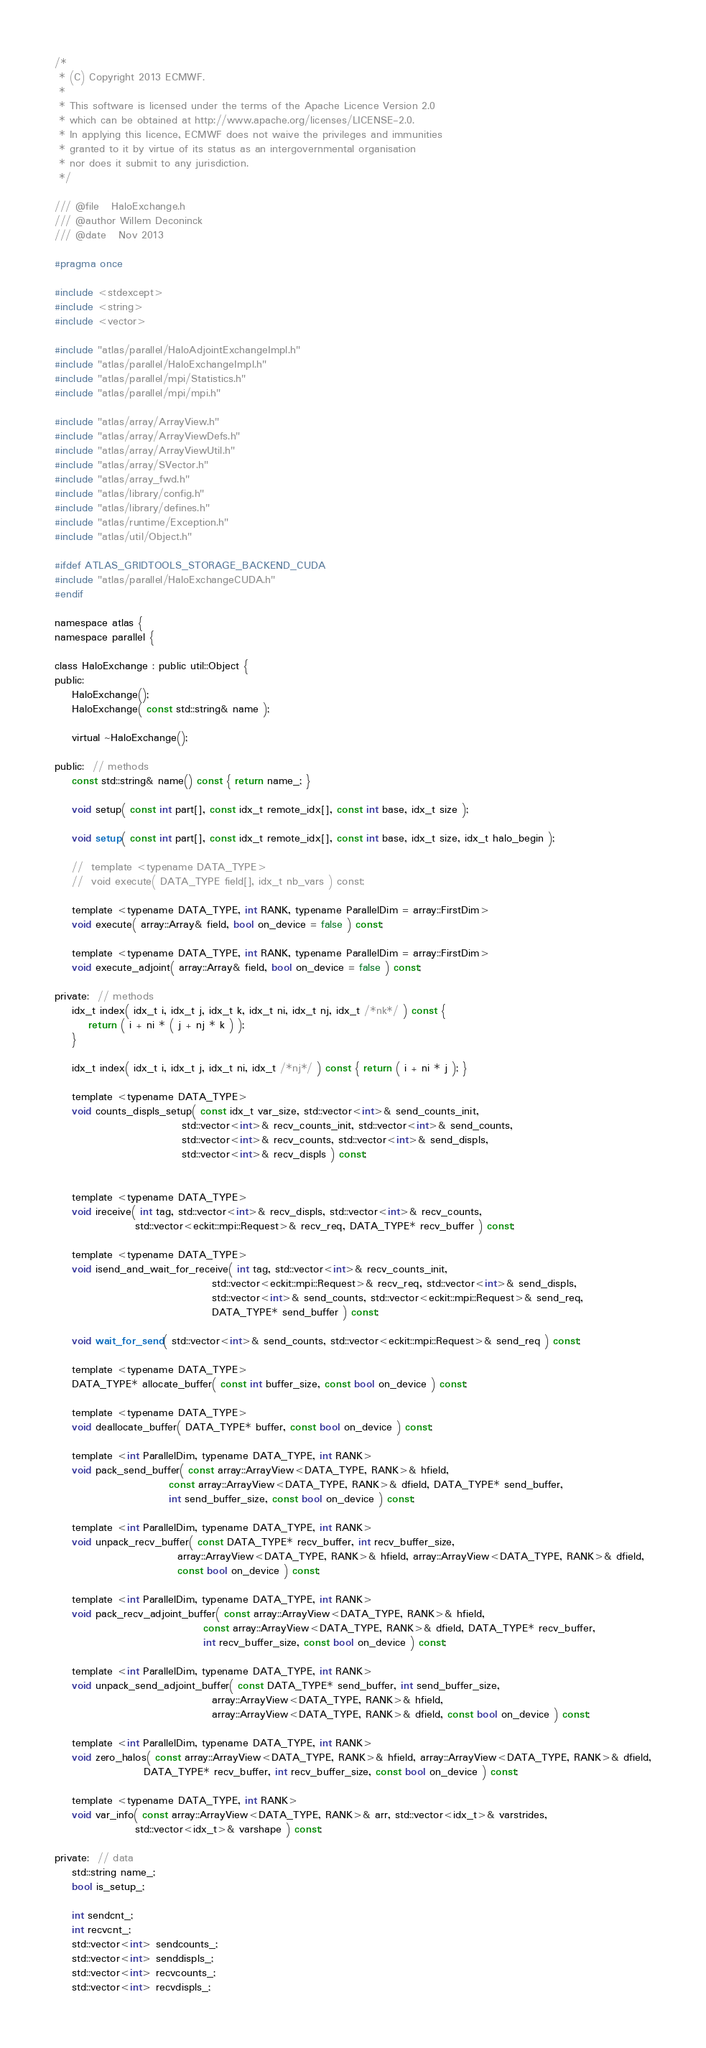<code> <loc_0><loc_0><loc_500><loc_500><_C_>/*
 * (C) Copyright 2013 ECMWF.
 *
 * This software is licensed under the terms of the Apache Licence Version 2.0
 * which can be obtained at http://www.apache.org/licenses/LICENSE-2.0.
 * In applying this licence, ECMWF does not waive the privileges and immunities
 * granted to it by virtue of its status as an intergovernmental organisation
 * nor does it submit to any jurisdiction.
 */

/// @file   HaloExchange.h
/// @author Willem Deconinck
/// @date   Nov 2013

#pragma once

#include <stdexcept>
#include <string>
#include <vector>

#include "atlas/parallel/HaloAdjointExchangeImpl.h"
#include "atlas/parallel/HaloExchangeImpl.h"
#include "atlas/parallel/mpi/Statistics.h"
#include "atlas/parallel/mpi/mpi.h"

#include "atlas/array/ArrayView.h"
#include "atlas/array/ArrayViewDefs.h"
#include "atlas/array/ArrayViewUtil.h"
#include "atlas/array/SVector.h"
#include "atlas/array_fwd.h"
#include "atlas/library/config.h"
#include "atlas/library/defines.h"
#include "atlas/runtime/Exception.h"
#include "atlas/util/Object.h"

#ifdef ATLAS_GRIDTOOLS_STORAGE_BACKEND_CUDA
#include "atlas/parallel/HaloExchangeCUDA.h"
#endif

namespace atlas {
namespace parallel {

class HaloExchange : public util::Object {
public:
    HaloExchange();
    HaloExchange( const std::string& name );

    virtual ~HaloExchange();

public:  // methods
    const std::string& name() const { return name_; }

    void setup( const int part[], const idx_t remote_idx[], const int base, idx_t size );

    void setup( const int part[], const idx_t remote_idx[], const int base, idx_t size, idx_t halo_begin );

    //  template <typename DATA_TYPE>
    //  void execute( DATA_TYPE field[], idx_t nb_vars ) const;

    template <typename DATA_TYPE, int RANK, typename ParallelDim = array::FirstDim>
    void execute( array::Array& field, bool on_device = false ) const;

    template <typename DATA_TYPE, int RANK, typename ParallelDim = array::FirstDim>
    void execute_adjoint( array::Array& field, bool on_device = false ) const;

private:  // methods
    idx_t index( idx_t i, idx_t j, idx_t k, idx_t ni, idx_t nj, idx_t /*nk*/ ) const {
        return ( i + ni * ( j + nj * k ) );
    }

    idx_t index( idx_t i, idx_t j, idx_t ni, idx_t /*nj*/ ) const { return ( i + ni * j ); }

    template <typename DATA_TYPE>
    void counts_displs_setup( const idx_t var_size, std::vector<int>& send_counts_init,
                              std::vector<int>& recv_counts_init, std::vector<int>& send_counts,
                              std::vector<int>& recv_counts, std::vector<int>& send_displs,
                              std::vector<int>& recv_displs ) const;


    template <typename DATA_TYPE>
    void ireceive( int tag, std::vector<int>& recv_displs, std::vector<int>& recv_counts,
                   std::vector<eckit::mpi::Request>& recv_req, DATA_TYPE* recv_buffer ) const;

    template <typename DATA_TYPE>
    void isend_and_wait_for_receive( int tag, std::vector<int>& recv_counts_init,
                                     std::vector<eckit::mpi::Request>& recv_req, std::vector<int>& send_displs,
                                     std::vector<int>& send_counts, std::vector<eckit::mpi::Request>& send_req,
                                     DATA_TYPE* send_buffer ) const;

    void wait_for_send( std::vector<int>& send_counts, std::vector<eckit::mpi::Request>& send_req ) const;

    template <typename DATA_TYPE>
    DATA_TYPE* allocate_buffer( const int buffer_size, const bool on_device ) const;

    template <typename DATA_TYPE>
    void deallocate_buffer( DATA_TYPE* buffer, const bool on_device ) const;

    template <int ParallelDim, typename DATA_TYPE, int RANK>
    void pack_send_buffer( const array::ArrayView<DATA_TYPE, RANK>& hfield,
                           const array::ArrayView<DATA_TYPE, RANK>& dfield, DATA_TYPE* send_buffer,
                           int send_buffer_size, const bool on_device ) const;

    template <int ParallelDim, typename DATA_TYPE, int RANK>
    void unpack_recv_buffer( const DATA_TYPE* recv_buffer, int recv_buffer_size,
                             array::ArrayView<DATA_TYPE, RANK>& hfield, array::ArrayView<DATA_TYPE, RANK>& dfield,
                             const bool on_device ) const;

    template <int ParallelDim, typename DATA_TYPE, int RANK>
    void pack_recv_adjoint_buffer( const array::ArrayView<DATA_TYPE, RANK>& hfield,
                                   const array::ArrayView<DATA_TYPE, RANK>& dfield, DATA_TYPE* recv_buffer,
                                   int recv_buffer_size, const bool on_device ) const;

    template <int ParallelDim, typename DATA_TYPE, int RANK>
    void unpack_send_adjoint_buffer( const DATA_TYPE* send_buffer, int send_buffer_size,
                                     array::ArrayView<DATA_TYPE, RANK>& hfield,
                                     array::ArrayView<DATA_TYPE, RANK>& dfield, const bool on_device ) const;

    template <int ParallelDim, typename DATA_TYPE, int RANK>
    void zero_halos( const array::ArrayView<DATA_TYPE, RANK>& hfield, array::ArrayView<DATA_TYPE, RANK>& dfield,
                     DATA_TYPE* recv_buffer, int recv_buffer_size, const bool on_device ) const;

    template <typename DATA_TYPE, int RANK>
    void var_info( const array::ArrayView<DATA_TYPE, RANK>& arr, std::vector<idx_t>& varstrides,
                   std::vector<idx_t>& varshape ) const;

private:  // data
    std::string name_;
    bool is_setup_;

    int sendcnt_;
    int recvcnt_;
    std::vector<int> sendcounts_;
    std::vector<int> senddispls_;
    std::vector<int> recvcounts_;
    std::vector<int> recvdispls_;</code> 